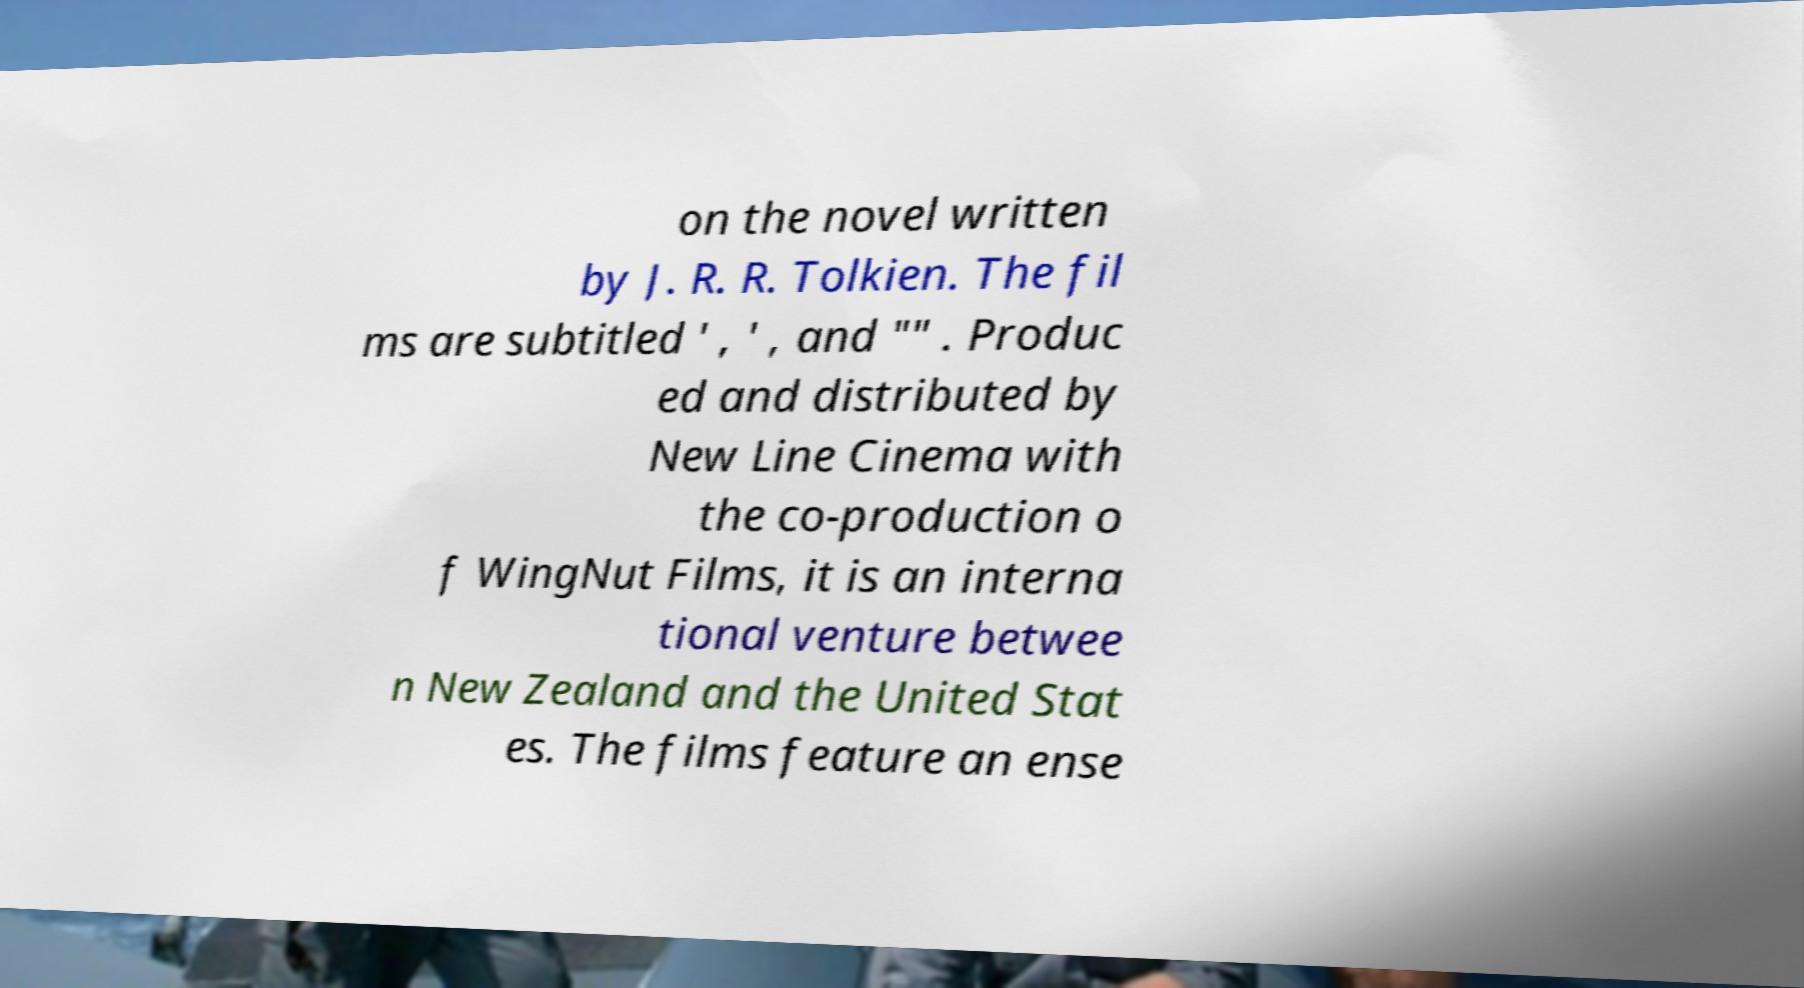Can you accurately transcribe the text from the provided image for me? on the novel written by J. R. R. Tolkien. The fil ms are subtitled ' , ' , and "" . Produc ed and distributed by New Line Cinema with the co-production o f WingNut Films, it is an interna tional venture betwee n New Zealand and the United Stat es. The films feature an ense 